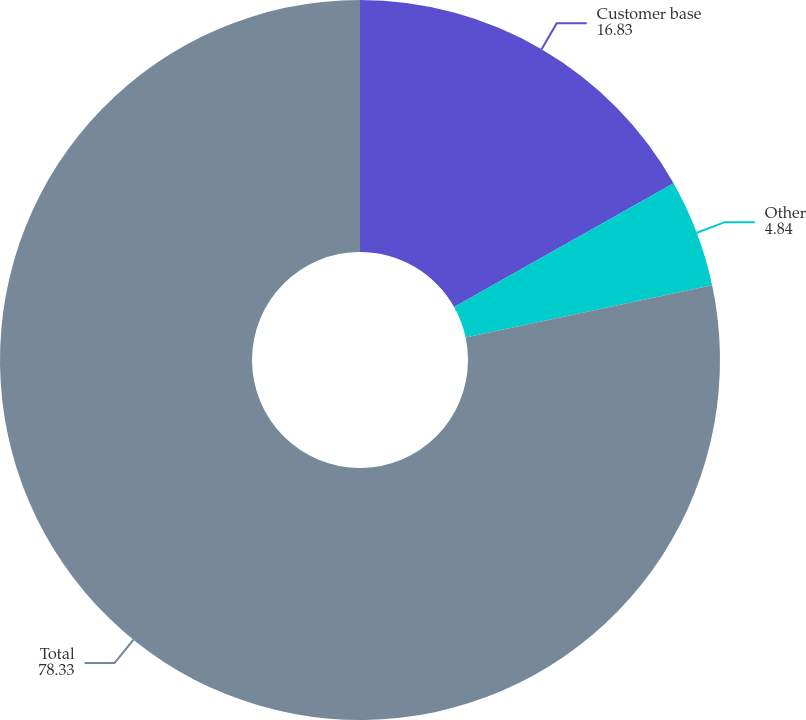Convert chart. <chart><loc_0><loc_0><loc_500><loc_500><pie_chart><fcel>Customer base<fcel>Other<fcel>Total<nl><fcel>16.83%<fcel>4.84%<fcel>78.33%<nl></chart> 